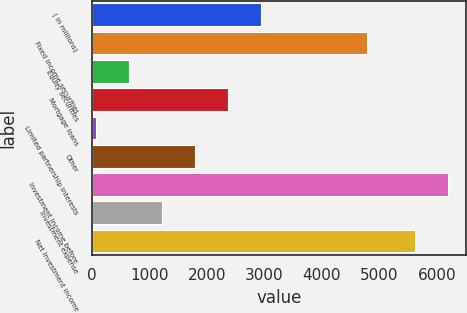Convert chart. <chart><loc_0><loc_0><loc_500><loc_500><bar_chart><fcel>( in millions)<fcel>Fixed income securities<fcel>Equity securities<fcel>Mortgage loans<fcel>Limited partnership interests<fcel>Other<fcel>Investment income before<fcel>Investment expense<fcel>Net investment income<nl><fcel>2947<fcel>4783<fcel>639<fcel>2370<fcel>62<fcel>1793<fcel>6199<fcel>1216<fcel>5622<nl></chart> 